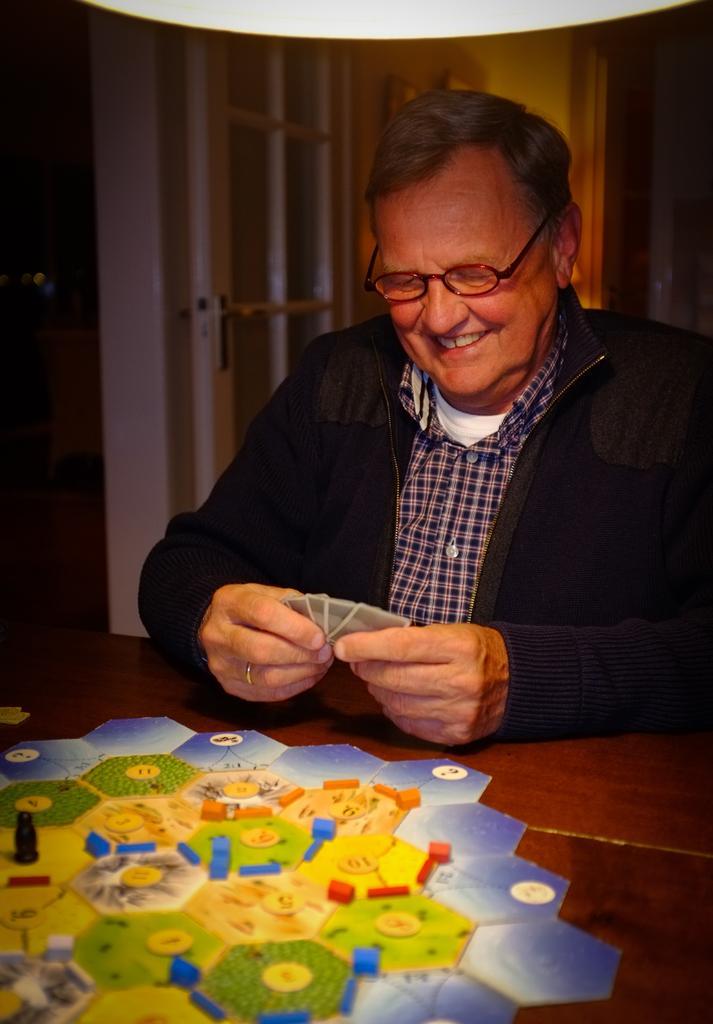Describe this image in one or two sentences. Here I can see a person wearing a jacket, holding few cards in the hands and smiling by looking at these cards. In front of this man there is a table on which I can see few blocks and a painting. In the background there is a door. 